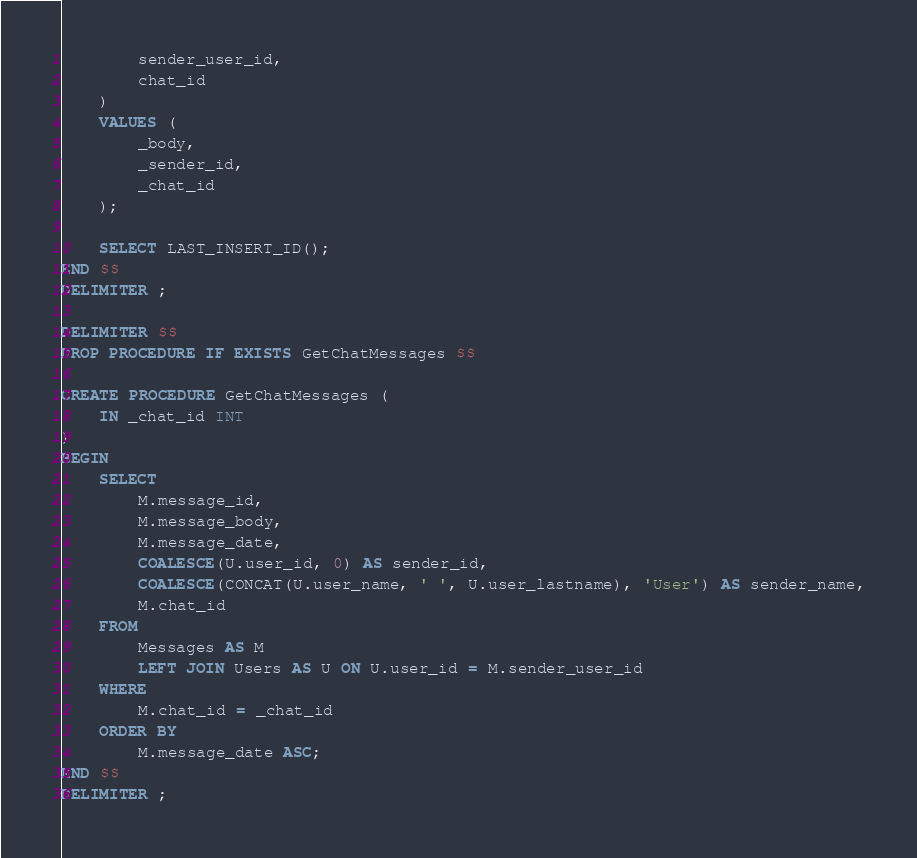Convert code to text. <code><loc_0><loc_0><loc_500><loc_500><_SQL_>        sender_user_id,
        chat_id
    )
    VALUES (
		_body,
        _sender_id,
        _chat_id
    );
    
    SELECT LAST_INSERT_ID();
END $$
DELIMITER ;

DELIMITER $$
DROP PROCEDURE IF EXISTS GetChatMessages $$

CREATE PROCEDURE GetChatMessages (
	IN _chat_id INT
)
BEGIN
	SELECT
		M.message_id,
		M.message_body,
		M.message_date,
        COALESCE(U.user_id, 0) AS sender_id,
        COALESCE(CONCAT(U.user_name, ' ', U.user_lastname), 'User') AS sender_name,
        M.chat_id
	FROM
		Messages AS M
        LEFT JOIN Users AS U ON U.user_id = M.sender_user_id
	WHERE
		M.chat_id = _chat_id
	ORDER BY
		M.message_date ASC;
END $$
DELIMITER ;
</code> 